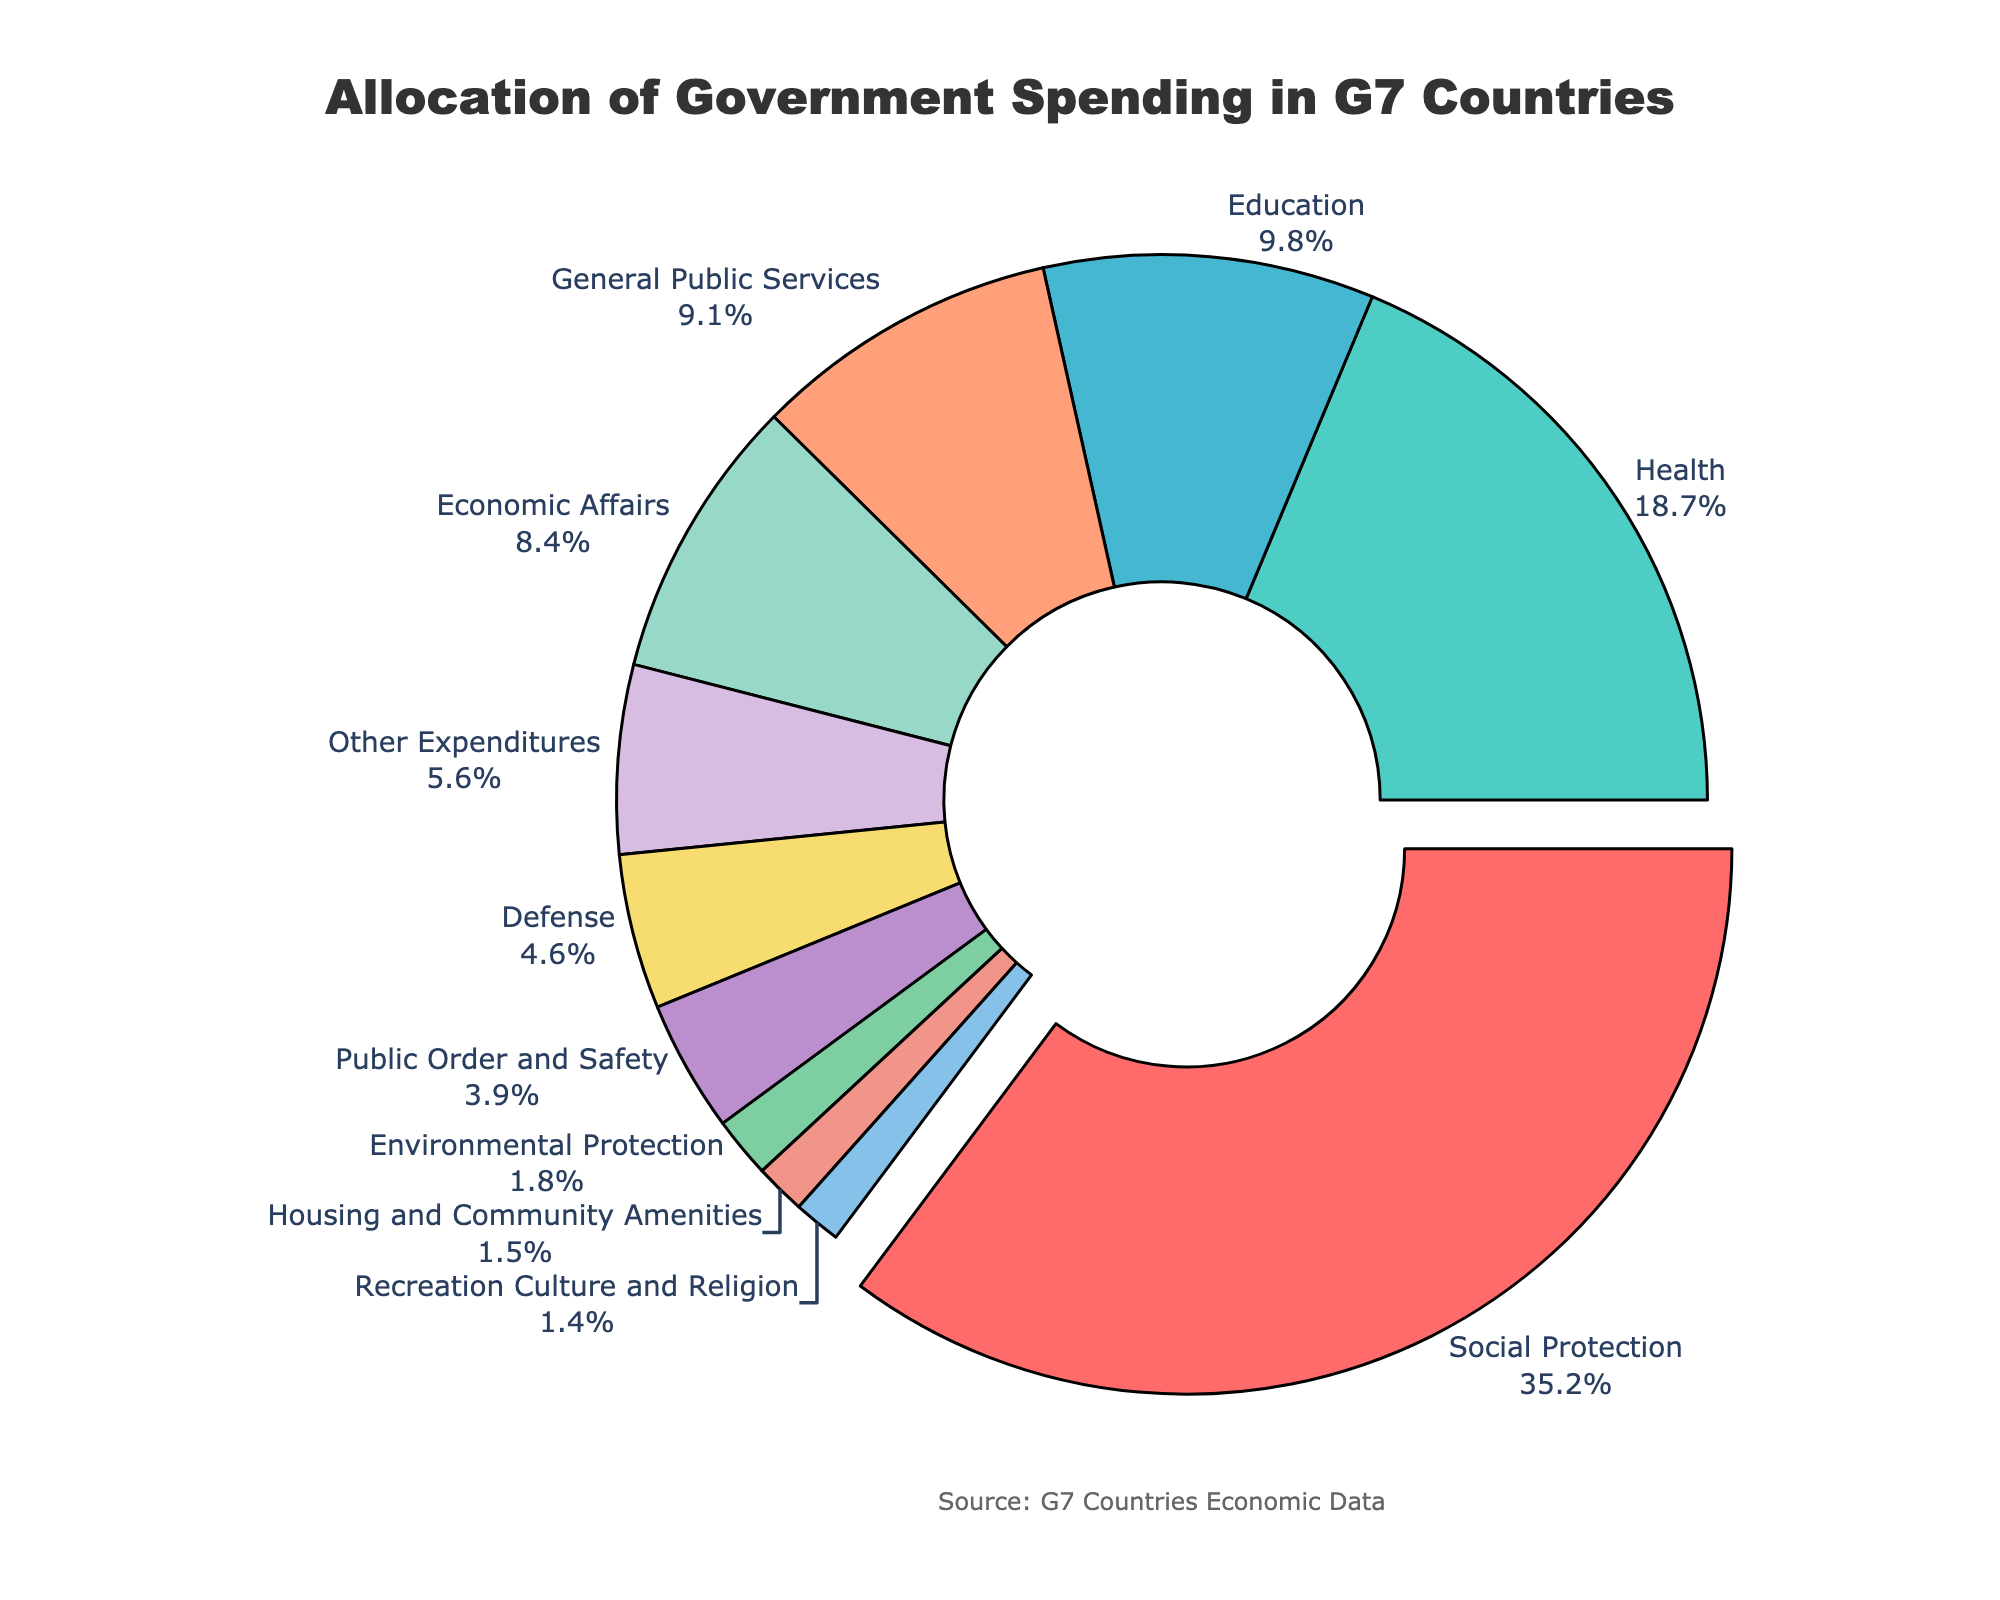What percentage of government spending is allocated to Health? To find the percentage allocated to Health, look at the corresponding slice of the pie chart.
Answer: 18.7% How much more is spent on Social Protection compared to Defense? Subtract the percentage spent on Defense from the percentage spent on Social Protection (35.2 - 4.6).
Answer: 30.6 Which category has the smallest allocation, and what is its percentage? Identify the smallest slice of the pie chart, which represents Recreation Culture and Religion, and note its percentage.
Answer: Recreation Culture and Religion, 1.4% What is the combined percentage for Education and Economic Affairs? Add the percentages allocated to Education and Economic Affairs (9.8 + 8.4).
Answer: 18.2% Which two categories have almost equal allocations, and what are their values? Identify the two slices that are close in size and have similar percentages: General Public Services and Economic Affairs (9.1% and 8.4%).
Answer: General Public Services (9.1%) and Economic Affairs (8.4%) What color represents the Social Protection category? Locate the Social Protection slice, which is pulled away from the pie chart, and observe its color (red).
Answer: Red What portion of the pie chart is allocated to categories other than Social Protection, Health, and Education? Subtract the combined percentage of Social Protection, Health, and Education from the total 100% (100 - (35.2 + 18.7 + 9.8) = 36.3%).
Answer: 36.3% How does the percentage allocated to Other Expenditures compare to that of Housing and Community Amenities? Compare the two slices' sizes, noting that Other Expenditures is larger (5.6%) than Housing and Community Amenities (1.5%).
Answer: Other Expenditures is larger How much more is spent on Health compared to Recreation Culture and Religion? Subtract the percentage of Recreation Culture and Religion from the percentage of Health (18.7 - 1.4).
Answer: 17.3% If the allocation for Environmental Protection doubled, what would be its new percentage, and how would it compare to the existing allocation for Defense? Double the current percentage for Environmental Protection (1.8 x 2 = 3.6). Compare it with the Defense percentage (4.6).
Answer: 3.6%, still less than Defense 